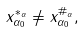<formula> <loc_0><loc_0><loc_500><loc_500>x _ { \alpha _ { 0 } } ^ { \ast _ { \alpha } } \neq x _ { \alpha _ { 0 } } ^ { \# _ { \alpha } } ,</formula> 